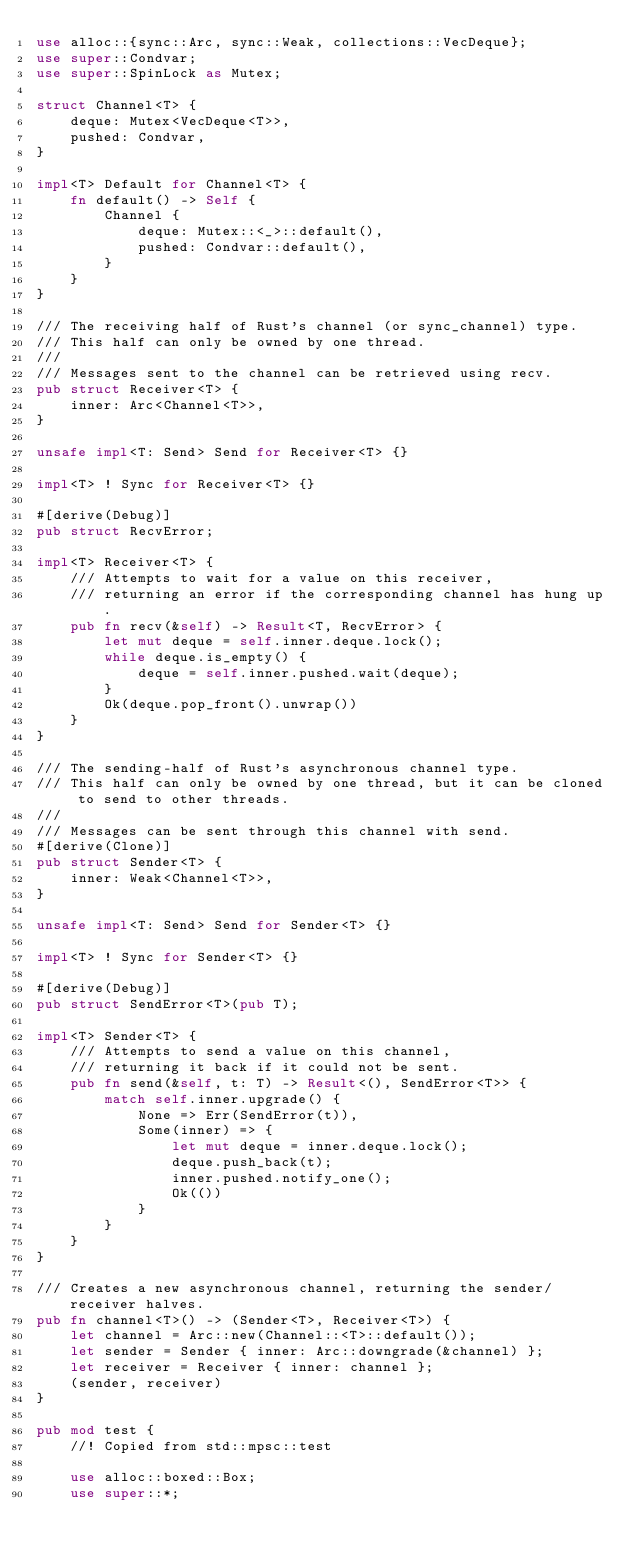<code> <loc_0><loc_0><loc_500><loc_500><_Rust_>use alloc::{sync::Arc, sync::Weak, collections::VecDeque};
use super::Condvar;
use super::SpinLock as Mutex;

struct Channel<T> {
    deque: Mutex<VecDeque<T>>,
    pushed: Condvar,
}

impl<T> Default for Channel<T> {
    fn default() -> Self {
        Channel {
            deque: Mutex::<_>::default(),
            pushed: Condvar::default(),
        }
    }
}

/// The receiving half of Rust's channel (or sync_channel) type.
/// This half can only be owned by one thread.
///
/// Messages sent to the channel can be retrieved using recv.
pub struct Receiver<T> {
    inner: Arc<Channel<T>>,
}

unsafe impl<T: Send> Send for Receiver<T> {}

impl<T> ! Sync for Receiver<T> {}

#[derive(Debug)]
pub struct RecvError;

impl<T> Receiver<T> {
    /// Attempts to wait for a value on this receiver,
    /// returning an error if the corresponding channel has hung up.
    pub fn recv(&self) -> Result<T, RecvError> {
        let mut deque = self.inner.deque.lock();
        while deque.is_empty() {
            deque = self.inner.pushed.wait(deque);
        }
        Ok(deque.pop_front().unwrap())
    }
}

/// The sending-half of Rust's asynchronous channel type.
/// This half can only be owned by one thread, but it can be cloned to send to other threads.
///
/// Messages can be sent through this channel with send.
#[derive(Clone)]
pub struct Sender<T> {
    inner: Weak<Channel<T>>,
}

unsafe impl<T: Send> Send for Sender<T> {}

impl<T> ! Sync for Sender<T> {}

#[derive(Debug)]
pub struct SendError<T>(pub T);

impl<T> Sender<T> {
    /// Attempts to send a value on this channel,
    /// returning it back if it could not be sent.
    pub fn send(&self, t: T) -> Result<(), SendError<T>> {
        match self.inner.upgrade() {
            None => Err(SendError(t)),
            Some(inner) => {
                let mut deque = inner.deque.lock();
                deque.push_back(t);
                inner.pushed.notify_one();
                Ok(())
            }
        }
    }
}

/// Creates a new asynchronous channel, returning the sender/receiver halves.
pub fn channel<T>() -> (Sender<T>, Receiver<T>) {
    let channel = Arc::new(Channel::<T>::default());
    let sender = Sender { inner: Arc::downgrade(&channel) };
    let receiver = Receiver { inner: channel };
    (sender, receiver)
}

pub mod test {
    //! Copied from std::mpsc::test

    use alloc::boxed::Box;
    use super::*;</code> 